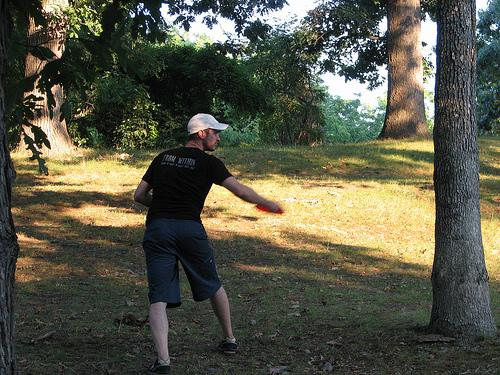Identify the total number of green leaves found in the image. There are 12 green leaves on the tree in this image. Count the number of visible limbs of the man, and describe the action or position of each limb. Four limbs are visible on the man; the right arm is holding a red frisbee, the left elbow is bent, the right foot is in a gym shoe, and the left foot is in another shoe. In a poetic way, describe what the man is doing in this image. Beneath the sun-dappled tree trunk, a spirited man prepares to release a red frisbee into the awaiting arms of the sky. Imagine you are a movie director. Create a short, one-sentence synopsis of a movie based on the image contents. An endearing tale of friendship and love blossoms when a group of friends, bonded by their love for frisbee, stumble upon a hidden world beneath sun-dappled trees. Express your opinion on the image quality considering the focus, lighting, and overall sharpness, along with the level of detail in the image. The image seems to have adequate focus and lighting, but the overall sharpness of the image could be improved for a better understanding of the different elements. Estimate the mood of the scene depicted in the image based on the presented visual elements. The mood of the scene appears to be fun and relaxed, with the man engaging in a recreational activity amidst a sunny day surrounded by nature. Characterize the socks the man is wearing with his sneakers. The man is wearing ankle socks with his dark sneakers. What is the prominent activity of the man in the scene? The man is about to throw a red frisbee. Please point out the small brown dog that's playing with the man and the frisbee. It looks like the dog is ready to jump and catch it! No, it's not mentioned in the image. Among the listed options, choose the closest description of the man's shirt: a) plain black shirt, b) black shirt with white stripes, c) black T-shirt with a print in white, d) white T-shirt with black images. c) black T-shirt with a print in white Select the correct statement: a) The man's shoes are the same color as his socks, b) The man has no socks, c) The man's shoes are lighter than his socks, d) The man's shoes are of different colors. a) The man's shoes are the same color as his socks Is there a green leaf on the tree? If so, describe its position. Yes, there are multiple green leaves on the tree, present on branches around the tree trunk. What item is the man preparing to use in the scene? The man is preparing to use a red frisbee. In a natural language sentence, describe the appearance of the trees. The trees have tall trunks, green leaves and sunlight shining on them, creating shadows on the ground. Please describe the man's attire in this image. The man is wearing a white baseball cap, a black t-shirt with white print, knee-length navy shorts, and dark sneakers with ankle socks. Can you find the yellow beach ball that's sitting on the grass behind the guy? It's slightly deflated and in need of some air. There is no mention of a yellow beach ball in any of the given image elements. The inclusion of the beach ball would be misleading since it does not exist in the image. Analyze the location where the man is positioned. The man is positioned on a sunny area of grass surrounded by tree trunks, green leaves, and dried leaves scattered on the ground. What color are the scattered leaves on the ground? The leaves are dried and brown. Do the shoes on the man's feet match? Yes, the shoes on the man's feet match. Describe the lighting and shadow conditions in this scene. There is sunlight dappled on the tree trunk and a shadow on the grass. Explain the relationship between the man and the nearby tree trunk. The man is standing near the tree trunk, but there is no direct interaction between them. Which objects are present behind the man in the scene? A sun-dappled tree trunk, dried leaves scattered on the ground, and a stick on the ground behind the man. Identify the pink and white ice cream truck parked near the tall green trees. Its catchy jingle must be attracting the frisbee players. There is nothing in the given image elements that suggests the presence of an ice cream truck. Asking someone to find this nonexistent object would mislead them. Locate the red and blue kites soaring in the sky above the scene, adding a playful element to the park setting. There is no mention of kites or any objects in the sky in the given image elements. Introducing kites into the scene would mislead the viewer as that is not part of the actual image. Is the man wearing a hat? If so, what color is it? Yes, the man is wearing a white hat. Where's the couple having a romantic picnic under the sun-dappled tree, complete with a blanket and a wicker basket filled with goodies? There are no objects relating to a couple, picnic, blanket, or wicker basket in the image. Creating a scenario with these objects would be misleading since they are not part of the actual image. Determine the connection between the frisbee and the man. The man is holding the frisbee in his right hand and is about to throw it. Reveal the state of the ground around the man. The ground around the man is covered in green grass and dried leaves, with shadows of trees on it. Is there any writing or text on the man's shirt? Yes, there is white writing on the man's black shirt. 